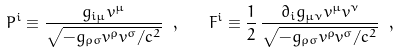<formula> <loc_0><loc_0><loc_500><loc_500>P ^ { i } \equiv \frac { g _ { i \mu } v ^ { \mu } } { \sqrt { - g _ { \rho \sigma } v ^ { \rho } v ^ { \sigma } / c ^ { 2 } } } \ , \quad F ^ { i } \equiv \frac { 1 } { 2 } \, \frac { \partial _ { i } g _ { \mu \nu } v ^ { \mu } v ^ { \nu } } { \sqrt { - g _ { \rho \sigma } v ^ { \rho } v ^ { \sigma } / c ^ { 2 } } } \ ,</formula> 